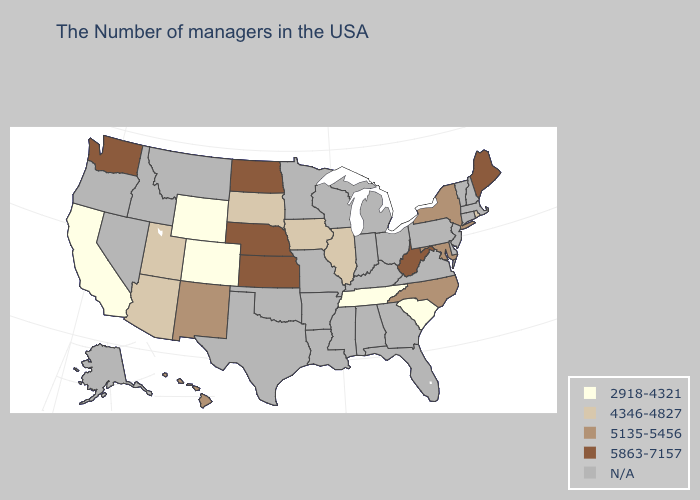Name the states that have a value in the range 4346-4827?
Concise answer only. Rhode Island, Illinois, Iowa, South Dakota, Utah, Arizona. Does the map have missing data?
Quick response, please. Yes. Does the map have missing data?
Concise answer only. Yes. What is the lowest value in the South?
Answer briefly. 2918-4321. What is the highest value in the USA?
Short answer required. 5863-7157. What is the lowest value in the MidWest?
Write a very short answer. 4346-4827. Which states have the lowest value in the MidWest?
Write a very short answer. Illinois, Iowa, South Dakota. Name the states that have a value in the range 2918-4321?
Concise answer only. South Carolina, Tennessee, Wyoming, Colorado, California. What is the highest value in the Northeast ?
Be succinct. 5863-7157. What is the value of South Carolina?
Concise answer only. 2918-4321. Is the legend a continuous bar?
Answer briefly. No. What is the value of Illinois?
Keep it brief. 4346-4827. Which states have the highest value in the USA?
Concise answer only. Maine, West Virginia, Kansas, Nebraska, North Dakota, Washington. Name the states that have a value in the range 5863-7157?
Write a very short answer. Maine, West Virginia, Kansas, Nebraska, North Dakota, Washington. Which states have the lowest value in the USA?
Answer briefly. South Carolina, Tennessee, Wyoming, Colorado, California. 